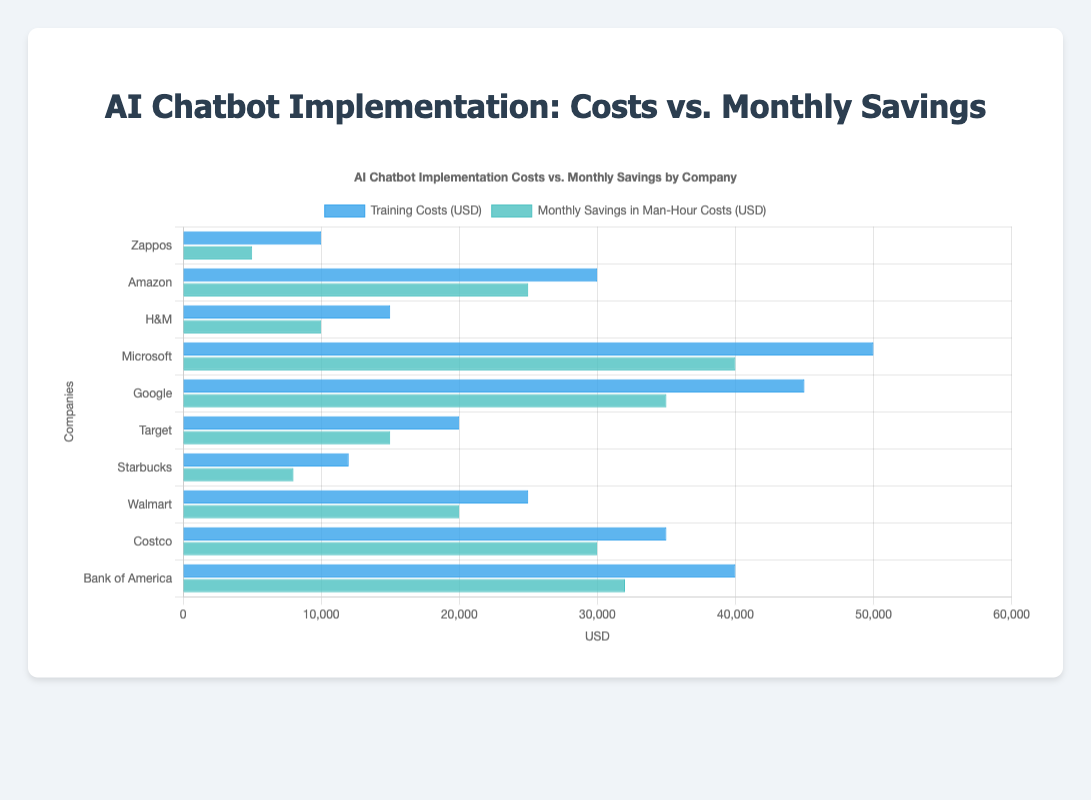Which company has the highest Training Costs (USD) for AI chatbot implementation? The bar representing Microsoft is the longest in the 'Training Costs (USD)' category, indicating it has the highest training costs.
Answer: Microsoft Which company has the lowest Monthly Savings in Man-Hour Costs (USD) for AI chatbot implementation? The bar representing Zappos is the shortest in the 'Monthly Savings in Man-Hour Costs (USD)' category, indicating it has the lowest savings.
Answer: Zappos How much more are Google's Training Costs (USD) compared to Walmart's? Google's training costs are 45000 USD and Walmart's are 25000 USD. The difference is 45000 - 25000 = 20000 USD.
Answer: 20000 Which two companies have the closest Monthly Savings in Man-Hour Costs (USD)? Costco and Google both have visually similar bar lengths for 'Monthly Savings in Man-Hour Costs (USD)', with Costco at 30000 USD and Google at 35000 USD, a difference of 5000 USD.
Answer: Costco, Google What is the average Training Costs (USD) for the companies? The training costs are: 10000, 30000, 15000, 50000, 45000, 20000, 12000, 25000, 35000, 40000. Summarized: 10000 + 30000 + 15000 + 50000 + 45000 + 20000 + 12000 + 25000 + 35000 + 40000 = 272000. Divided by 10 companies: 272000 / 10 = 27200 USD.
Answer: 27200 What is the total Monthly Savings in Man-Hour Costs (USD) across all companies? The monthly savings are: 5000, 25000, 10000, 40000, 35000, 15000, 8000, 20000, 30000, 32000. Summarized: 5000 + 25000 + 10000 + 40000 + 35000 + 15000 + 8000 + 20000 + 30000 + 32000 = 220000 USD.
Answer: 220000 Are there any companies where Monthly Savings in Man-Hour Costs (USD) is less than their Training Costs (USD)? For each company, compare monthly savings to training costs: 
 Zappos: 5000 < 10000,
 H&M: 10000 < 15000,
 Starbucks: 8000 < 12000.
 These three companies have lower monthly savings than training costs.
Answer: Zappos, H&M, Starbucks Which company has a Training Costs (USD) that is twice the amount of Target's? Target has Training Costs of 20000 USD. Doubling that is 40000 USD, which matches the training costs for Bank of America.
Answer: Bank of America By how much does Microsoft's Monthly Savings in Man-Hour Costs (USD) exceed its Training Costs (USD)? Microsoft's Monthly Savings are 40000 USD and its Training Costs are 50000 USD. The difference: 50000 - 40000 = 10000 USD.
Answer: 10000 What is the combined Monthly Savings in Man-Hour Costs (USD) for Amazon and Walmart? Amazon's savings are 25000 USD and Walmart's are 20000 USD. Summed: 25000 + 20000 = 45000 USD.
Answer: 45000 